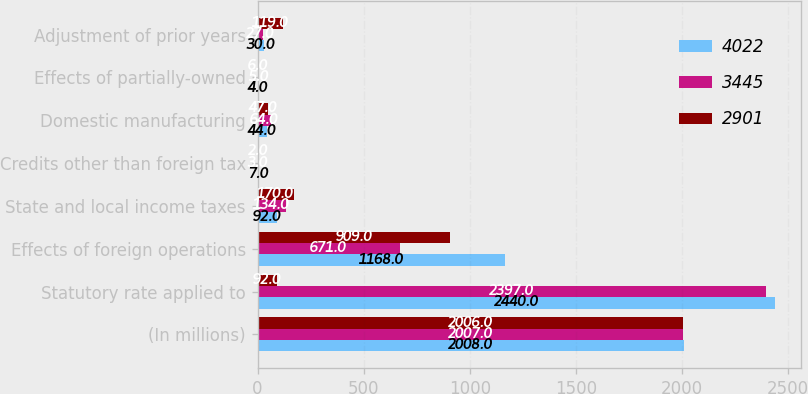Convert chart to OTSL. <chart><loc_0><loc_0><loc_500><loc_500><stacked_bar_chart><ecel><fcel>(In millions)<fcel>Statutory rate applied to<fcel>Effects of foreign operations<fcel>State and local income taxes<fcel>Credits other than foreign tax<fcel>Domestic manufacturing<fcel>Effects of partially-owned<fcel>Adjustment of prior years<nl><fcel>4022<fcel>2008<fcel>2440<fcel>1168<fcel>92<fcel>7<fcel>44<fcel>4<fcel>30<nl><fcel>3445<fcel>2007<fcel>2397<fcel>671<fcel>134<fcel>3<fcel>64<fcel>5<fcel>27<nl><fcel>2901<fcel>2006<fcel>92<fcel>909<fcel>170<fcel>2<fcel>47<fcel>6<fcel>119<nl></chart> 